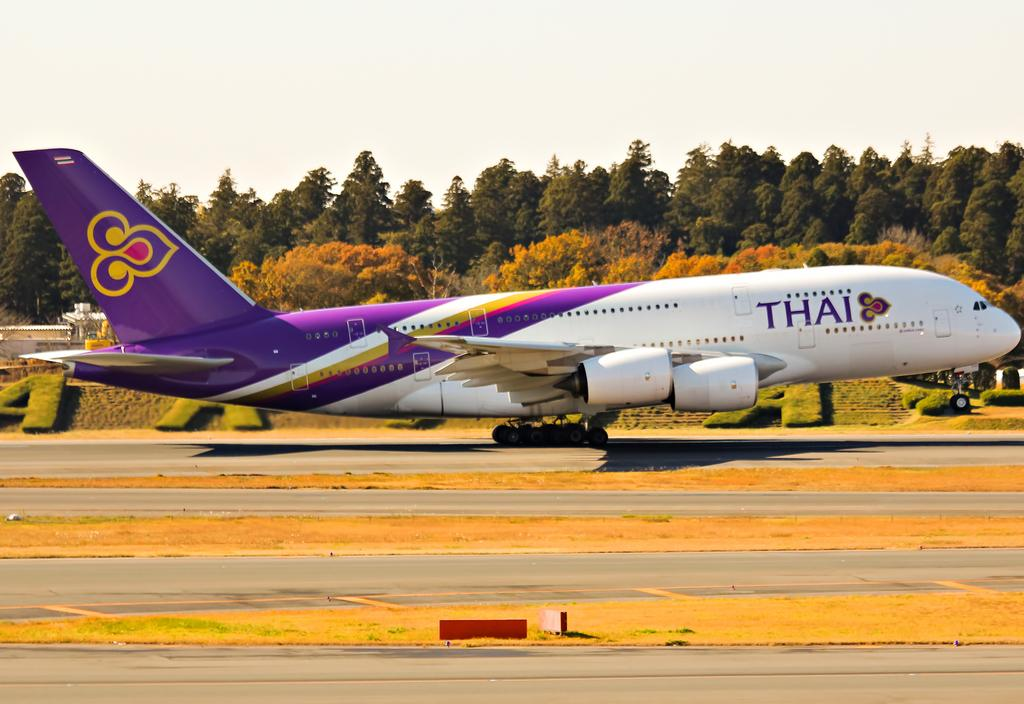<image>
Write a terse but informative summary of the picture. a purple, orang and white plain with a thai airlines logo on it. 